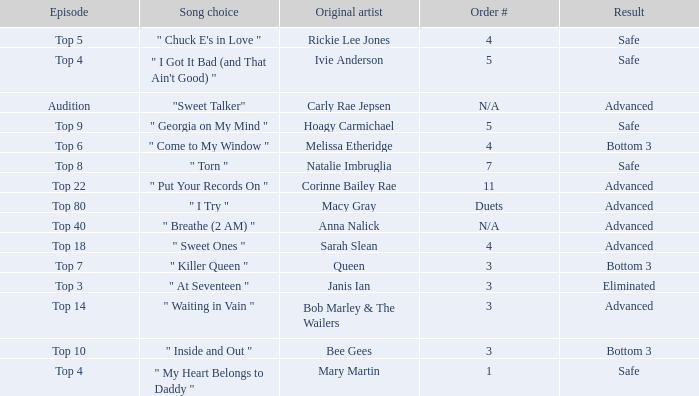I'm looking to parse the entire table for insights. Could you assist me with that? {'header': ['Episode', 'Song choice', 'Original artist', 'Order #', 'Result'], 'rows': [['Top 5', '" Chuck E\'s in Love "', 'Rickie Lee Jones', '4', 'Safe'], ['Top 4', '" I Got It Bad (and That Ain\'t Good) "', 'Ivie Anderson', '5', 'Safe'], ['Audition', '"Sweet Talker"', 'Carly Rae Jepsen', 'N/A', 'Advanced'], ['Top 9', '" Georgia on My Mind "', 'Hoagy Carmichael', '5', 'Safe'], ['Top 6', '" Come to My Window "', 'Melissa Etheridge', '4', 'Bottom 3'], ['Top 8', '" Torn "', 'Natalie Imbruglia', '7', 'Safe'], ['Top 22', '" Put Your Records On "', 'Corinne Bailey Rae', '11', 'Advanced'], ['Top 80', '" I Try "', 'Macy Gray', 'Duets', 'Advanced'], ['Top 40', '" Breathe (2 AM) "', 'Anna Nalick', 'N/A', 'Advanced'], ['Top 18', '" Sweet Ones "', 'Sarah Slean', '4', 'Advanced'], ['Top 7', '" Killer Queen "', 'Queen', '3', 'Bottom 3'], ['Top 3', '" At Seventeen "', 'Janis Ian', '3', 'Eliminated'], ['Top 14', '" Waiting in Vain "', 'Bob Marley & The Wailers', '3', 'Advanced'], ['Top 10', '" Inside and Out "', 'Bee Gees', '3', 'Bottom 3'], ['Top 4', '" My Heart Belongs to Daddy "', 'Mary Martin', '1', 'Safe']]} Which one of the songs was originally performed by Rickie Lee Jones? " Chuck E's in Love ". 